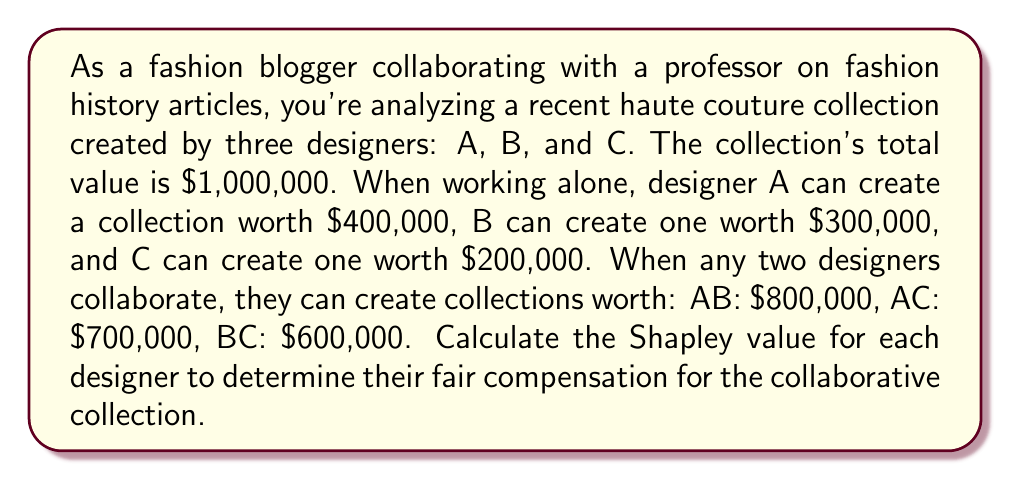Give your solution to this math problem. To calculate the Shapley value, we need to consider all possible coalitions and the marginal contributions of each designer. Let's follow these steps:

1. List all possible coalitions:
   $\{\}, \{A\}, \{B\}, \{C\}, \{A,B\}, \{A,C\}, \{B,C\}, \{A,B,C\}$

2. Calculate the value of each coalition:
   $v(\{\}) = 0$
   $v(\{A\}) = 400,000$
   $v(\{B\}) = 300,000$
   $v(\{C\}) = 200,000$
   $v(\{A,B\}) = 800,000$
   $v(\{A,C\}) = 700,000$
   $v(\{B,C\}) = 600,000$
   $v(\{A,B,C\}) = 1,000,000$

3. Calculate marginal contributions for each designer in all possible orders:

   ABC: A: 400,000, B: 400,000, C: 200,000
   ACB: A: 400,000, C: 300,000, B: 300,000
   BAC: B: 300,000, A: 500,000, C: 200,000
   BCA: B: 300,000, C: 300,000, A: 400,000
   CAB: C: 200,000, A: 500,000, B: 300,000
   CBA: C: 200,000, B: 400,000, A: 400,000

4. Calculate the average marginal contribution for each designer:

   Designer A: $\frac{400,000 + 400,000 + 500,000 + 400,000 + 500,000 + 400,000}{6} = 433,333.33$

   Designer B: $\frac{400,000 + 300,000 + 300,000 + 300,000 + 300,000 + 400,000}{6} = 333,333.33$

   Designer C: $\frac{200,000 + 300,000 + 200,000 + 300,000 + 200,000 + 200,000}{6} = 233,333.33$

5. Verify that the sum of Shapley values equals the total value:
   $433,333.33 + 333,333.33 + 233,333.33 = 1,000,000$

The Shapley value represents the fair compensation for each designer based on their marginal contributions to all possible coalitions.
Answer: The Shapley values for the designers are:

Designer A: $433,333.33
Designer B: $333,333.33
Designer C: $233,333.33 